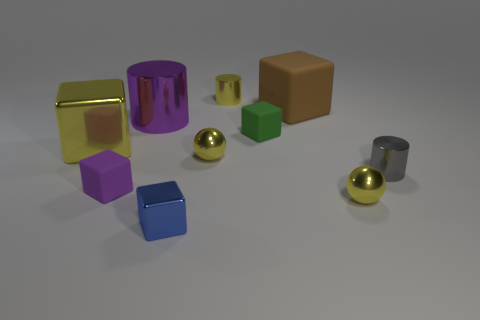Subtract all yellow balls. How many were subtracted if there are1yellow balls left? 1 Subtract 2 blocks. How many blocks are left? 3 Subtract all purple cubes. How many cubes are left? 4 Subtract all yellow cubes. How many cubes are left? 4 Subtract all cyan cubes. Subtract all gray cylinders. How many cubes are left? 5 Subtract all spheres. How many objects are left? 8 Add 9 blue metal blocks. How many blue metal blocks exist? 10 Subtract 0 blue cylinders. How many objects are left? 10 Subtract all small green blocks. Subtract all metallic things. How many objects are left? 2 Add 6 blue cubes. How many blue cubes are left? 7 